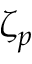Convert formula to latex. <formula><loc_0><loc_0><loc_500><loc_500>\zeta _ { p }</formula> 